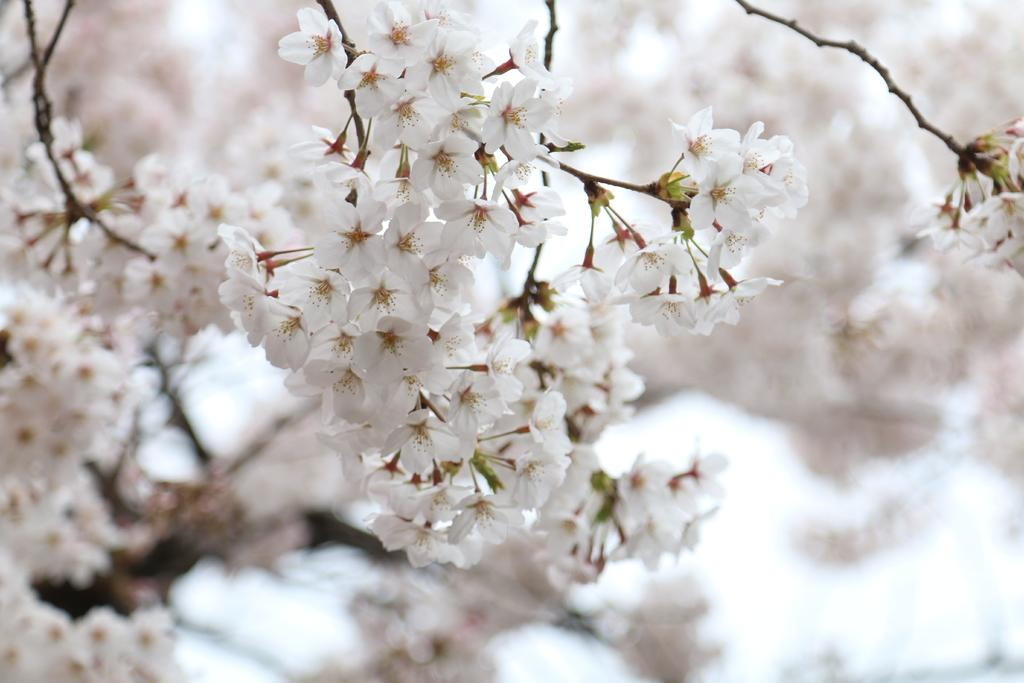What type of flowers can be seen on the plant in the image? There are white flowers on a plant in the image. Are there any other flowers visible in the image? Yes, there are flowers in the background of the image. How would you describe the appearance of the background in the image? The background of the image is blurred. How does the cork help the flowers in the image? There is no cork present in the image, so it cannot help the flowers. 